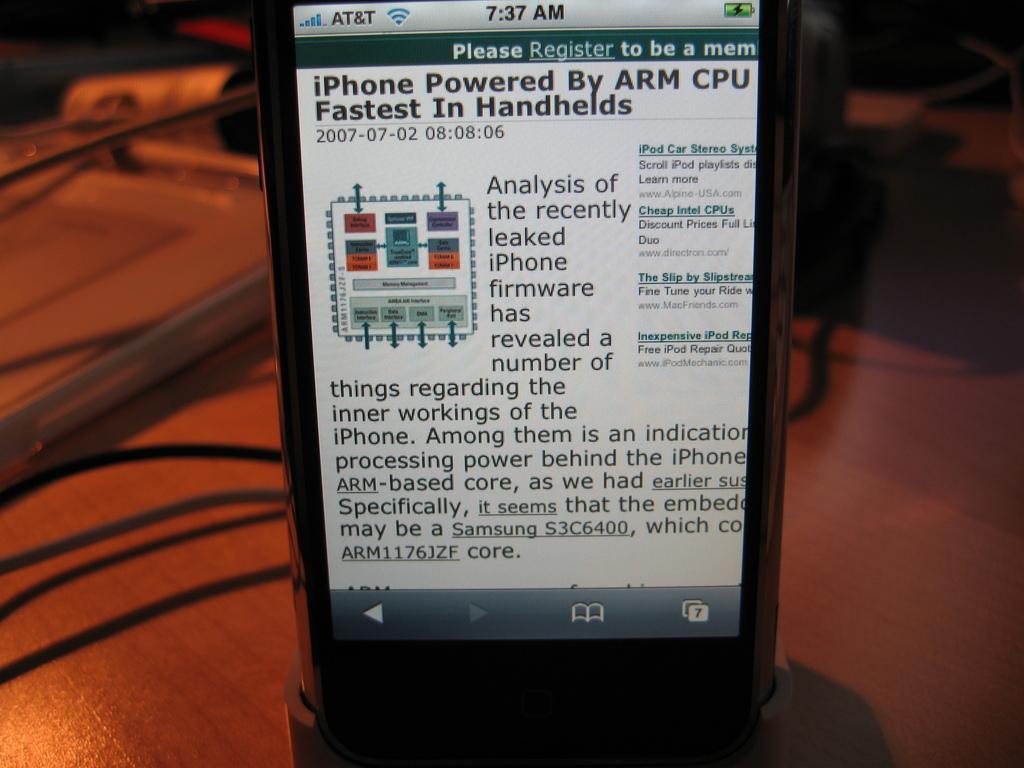Please provide a concise description of this image. This is a mobile phone, with a display. I think these are the cables and an object, which are placed on the wooden table. The background looks blurry. 